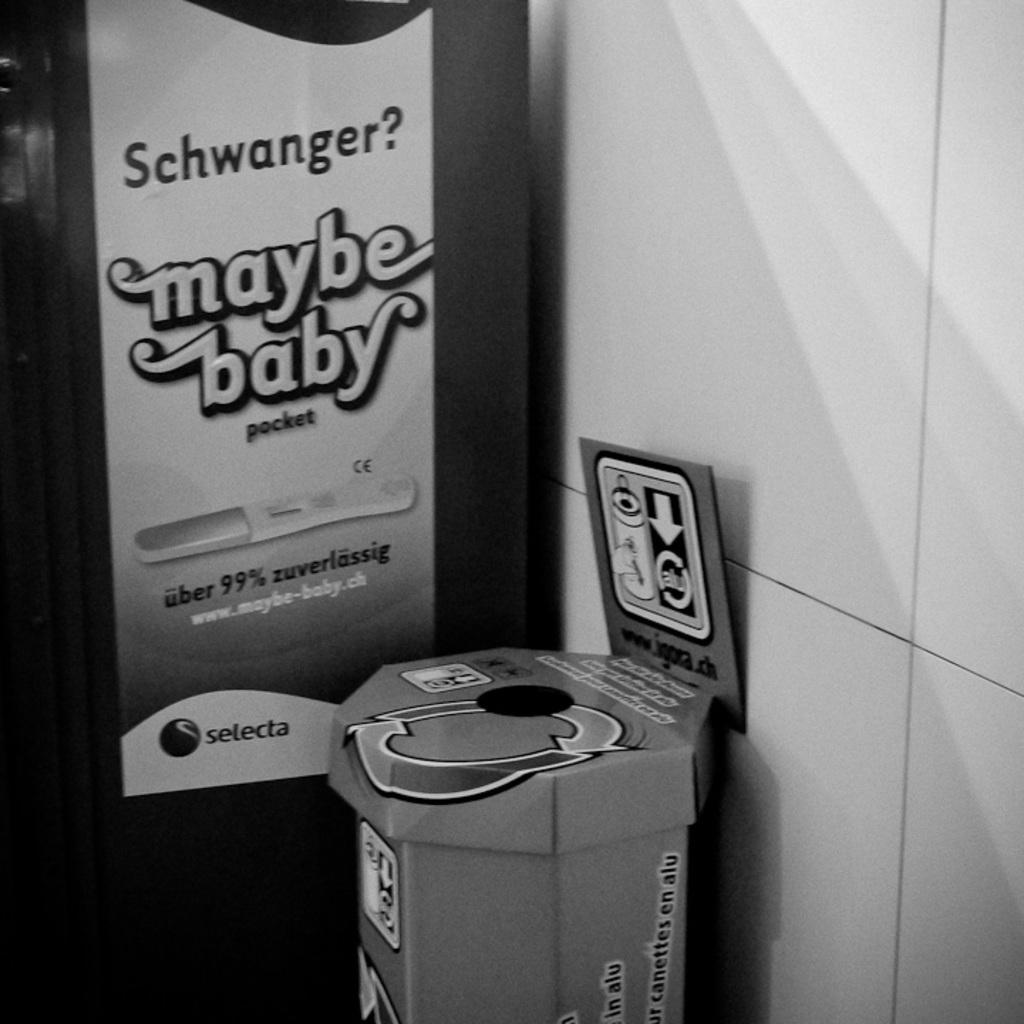<image>
Offer a succinct explanation of the picture presented. Garbage bin along the wall with a maybe baby advertisement next to it. 